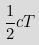Convert formula to latex. <formula><loc_0><loc_0><loc_500><loc_500>\frac { 1 } { 2 } c T</formula> 